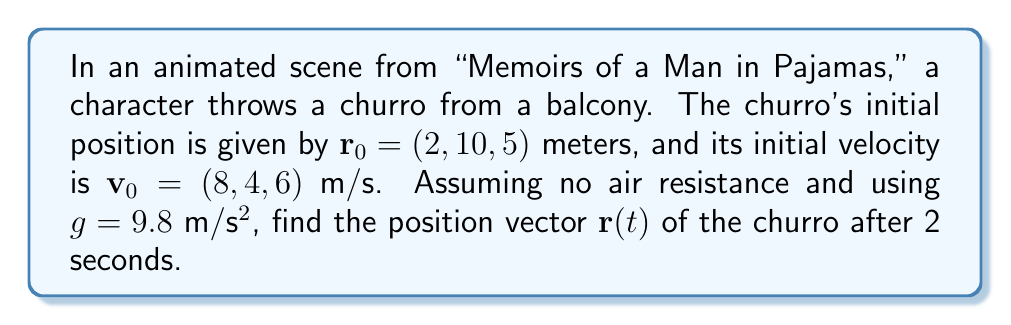Teach me how to tackle this problem. To solve this problem, we'll use the vector calculus approach for analyzing the trajectory of a thrown object:

1) The position vector $\mathbf{r}(t)$ of an object under constant acceleration is given by:

   $$\mathbf{r}(t) = \mathbf{r}_0 + \mathbf{v}_0t + \frac{1}{2}\mathbf{a}t^2$$

2) In this case, the acceleration is due to gravity: $\mathbf{a} = (0, 0, -g) = (0, 0, -9.8)$ m/s²

3) Substituting the given values:

   $$\mathbf{r}(t) = (2, 10, 5) + (8, 4, 6)t + \frac{1}{2}(0, 0, -9.8)t^2$$

4) Simplifying:

   $$\mathbf{r}(t) = (2 + 8t, 10 + 4t, 5 + 6t - 4.9t^2)$$

5) For t = 2 seconds:

   $$\mathbf{r}(2) = (2 + 8(2), 10 + 4(2), 5 + 6(2) - 4.9(2)^2)$$
   
   $$\mathbf{r}(2) = (18, 18, 5.4)$$

Therefore, after 2 seconds, the position vector of the churro is (18, 18, 5.4) meters.
Answer: $(18, 18, 5.4)$ meters 